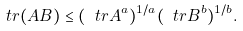Convert formula to latex. <formula><loc_0><loc_0><loc_500><loc_500>\ t r ( A B ) \leq ( \ t r A ^ { a } ) ^ { 1 / a } ( \ t r B ^ { b } ) ^ { 1 / b } .</formula> 